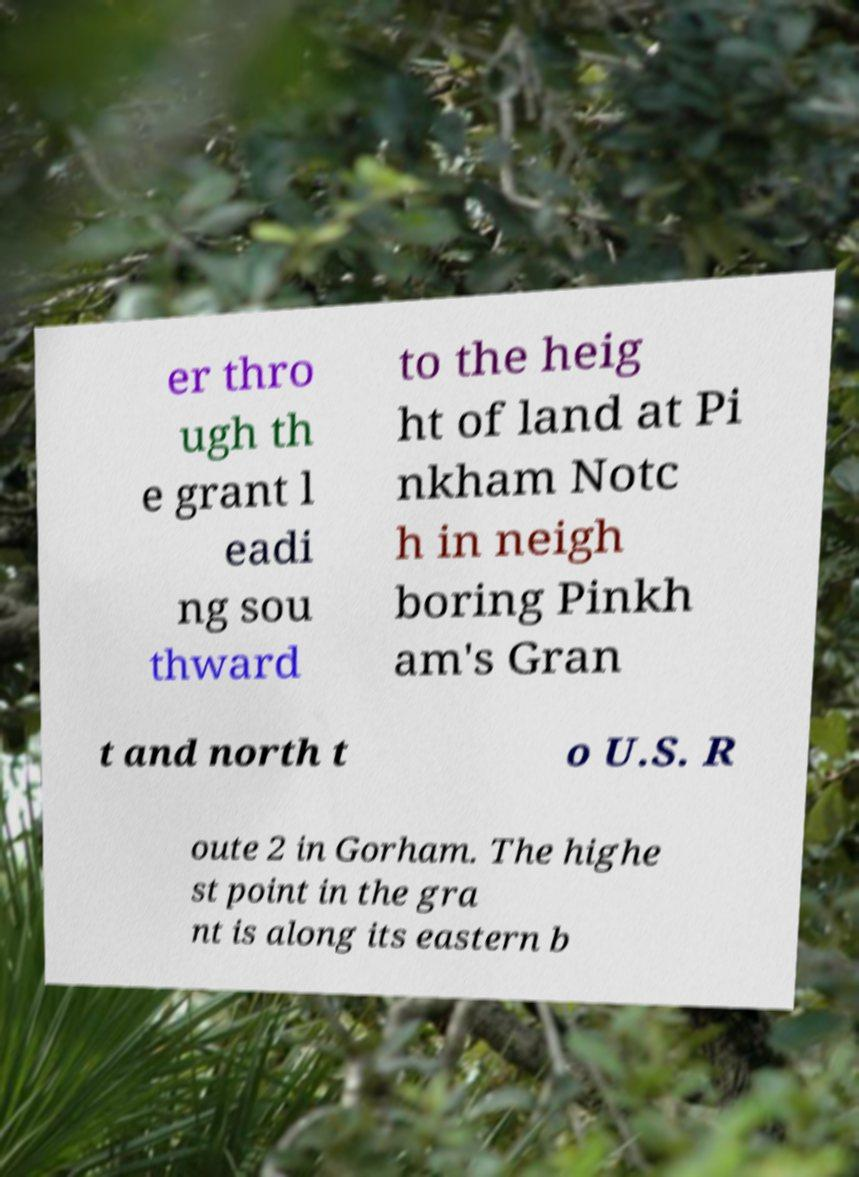Could you assist in decoding the text presented in this image and type it out clearly? er thro ugh th e grant l eadi ng sou thward to the heig ht of land at Pi nkham Notc h in neigh boring Pinkh am's Gran t and north t o U.S. R oute 2 in Gorham. The highe st point in the gra nt is along its eastern b 